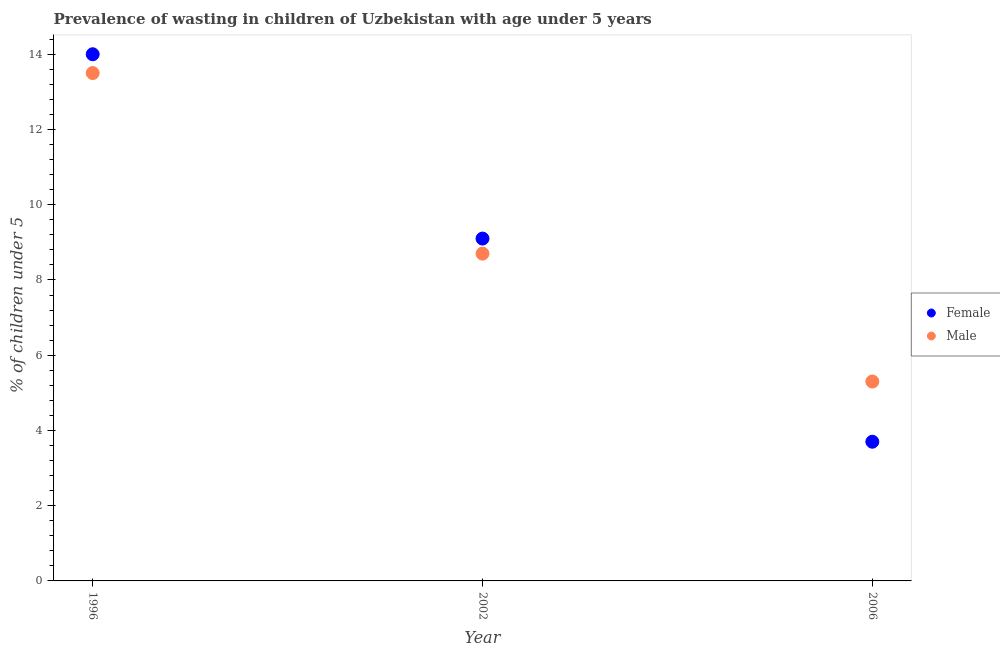How many different coloured dotlines are there?
Make the answer very short. 2. What is the percentage of undernourished female children in 2002?
Offer a terse response. 9.1. Across all years, what is the minimum percentage of undernourished female children?
Offer a very short reply. 3.7. In which year was the percentage of undernourished female children minimum?
Your response must be concise. 2006. What is the difference between the percentage of undernourished female children in 2002 and that in 2006?
Offer a very short reply. 5.4. What is the difference between the percentage of undernourished male children in 2006 and the percentage of undernourished female children in 2002?
Your response must be concise. -3.8. What is the average percentage of undernourished male children per year?
Make the answer very short. 9.17. In the year 2006, what is the difference between the percentage of undernourished female children and percentage of undernourished male children?
Offer a very short reply. -1.6. What is the ratio of the percentage of undernourished male children in 1996 to that in 2002?
Ensure brevity in your answer.  1.55. What is the difference between the highest and the second highest percentage of undernourished female children?
Provide a succinct answer. 4.9. What is the difference between the highest and the lowest percentage of undernourished male children?
Ensure brevity in your answer.  8.2. Is the percentage of undernourished female children strictly less than the percentage of undernourished male children over the years?
Provide a succinct answer. No. How many dotlines are there?
Your answer should be very brief. 2. How many years are there in the graph?
Offer a very short reply. 3. What is the difference between two consecutive major ticks on the Y-axis?
Make the answer very short. 2. Does the graph contain any zero values?
Keep it short and to the point. No. Where does the legend appear in the graph?
Give a very brief answer. Center right. How many legend labels are there?
Keep it short and to the point. 2. What is the title of the graph?
Keep it short and to the point. Prevalence of wasting in children of Uzbekistan with age under 5 years. What is the label or title of the Y-axis?
Your response must be concise.  % of children under 5. What is the  % of children under 5 of Female in 2002?
Provide a short and direct response. 9.1. What is the  % of children under 5 of Male in 2002?
Offer a very short reply. 8.7. What is the  % of children under 5 in Female in 2006?
Give a very brief answer. 3.7. What is the  % of children under 5 in Male in 2006?
Offer a very short reply. 5.3. Across all years, what is the maximum  % of children under 5 of Female?
Offer a very short reply. 14. Across all years, what is the maximum  % of children under 5 in Male?
Provide a succinct answer. 13.5. Across all years, what is the minimum  % of children under 5 of Female?
Keep it short and to the point. 3.7. Across all years, what is the minimum  % of children under 5 of Male?
Provide a succinct answer. 5.3. What is the total  % of children under 5 in Female in the graph?
Give a very brief answer. 26.8. What is the total  % of children under 5 of Male in the graph?
Offer a terse response. 27.5. What is the difference between the  % of children under 5 of Female in 1996 and that in 2002?
Keep it short and to the point. 4.9. What is the difference between the  % of children under 5 in Male in 2002 and that in 2006?
Your response must be concise. 3.4. What is the difference between the  % of children under 5 of Female in 1996 and the  % of children under 5 of Male in 2002?
Ensure brevity in your answer.  5.3. What is the difference between the  % of children under 5 in Female in 2002 and the  % of children under 5 in Male in 2006?
Make the answer very short. 3.8. What is the average  % of children under 5 of Female per year?
Make the answer very short. 8.93. What is the average  % of children under 5 in Male per year?
Your response must be concise. 9.17. In the year 1996, what is the difference between the  % of children under 5 of Female and  % of children under 5 of Male?
Provide a succinct answer. 0.5. What is the ratio of the  % of children under 5 of Female in 1996 to that in 2002?
Ensure brevity in your answer.  1.54. What is the ratio of the  % of children under 5 of Male in 1996 to that in 2002?
Make the answer very short. 1.55. What is the ratio of the  % of children under 5 of Female in 1996 to that in 2006?
Provide a succinct answer. 3.78. What is the ratio of the  % of children under 5 in Male in 1996 to that in 2006?
Offer a terse response. 2.55. What is the ratio of the  % of children under 5 in Female in 2002 to that in 2006?
Provide a succinct answer. 2.46. What is the ratio of the  % of children under 5 of Male in 2002 to that in 2006?
Your response must be concise. 1.64. What is the difference between the highest and the second highest  % of children under 5 in Male?
Provide a succinct answer. 4.8. What is the difference between the highest and the lowest  % of children under 5 of Female?
Your answer should be very brief. 10.3. 